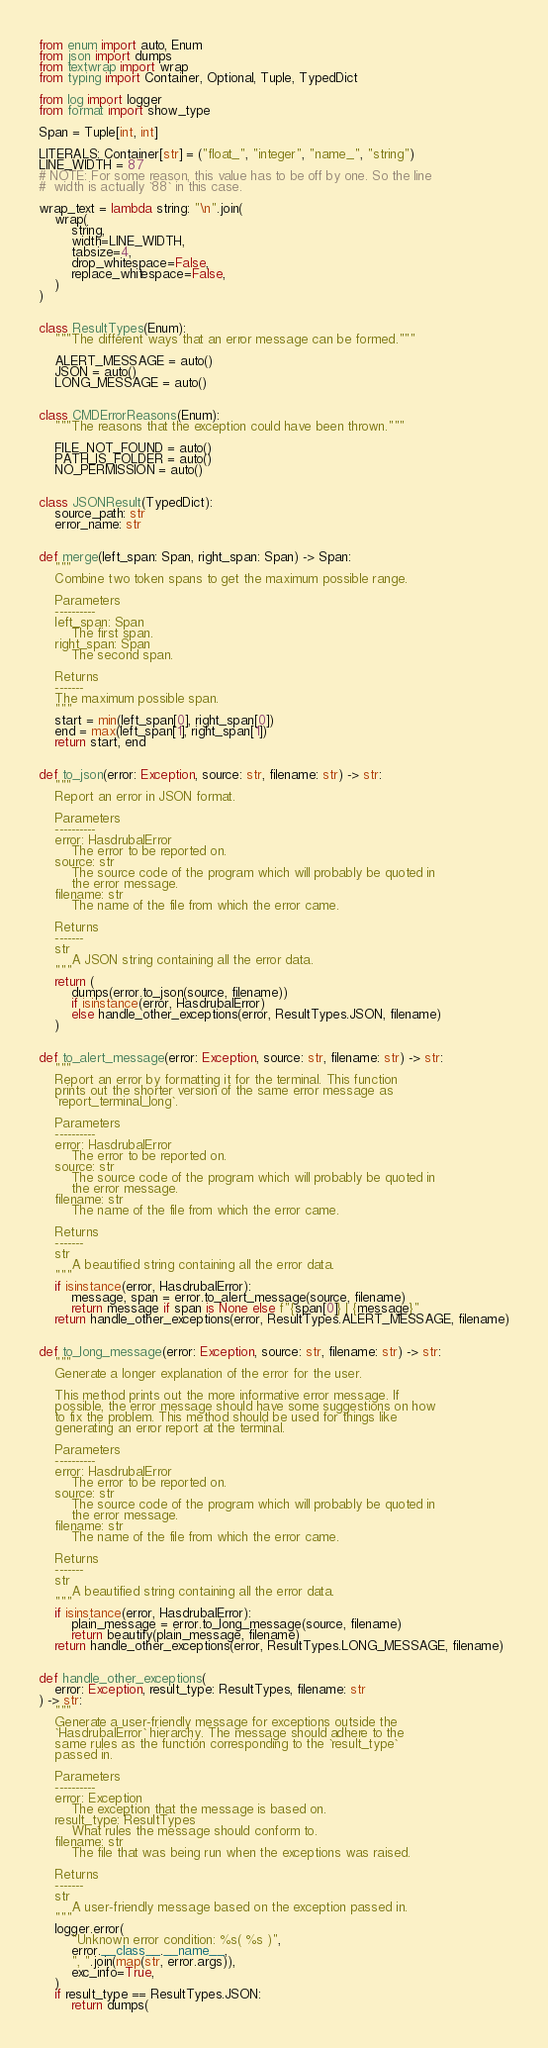<code> <loc_0><loc_0><loc_500><loc_500><_Python_>from enum import auto, Enum
from json import dumps
from textwrap import wrap
from typing import Container, Optional, Tuple, TypedDict

from log import logger
from format import show_type

Span = Tuple[int, int]

LITERALS: Container[str] = ("float_", "integer", "name_", "string")
LINE_WIDTH = 87
# NOTE: For some reason, this value has to be off by one. So the line
#  width is actually `88` in this case.

wrap_text = lambda string: "\n".join(
    wrap(
        string,
        width=LINE_WIDTH,
        tabsize=4,
        drop_whitespace=False,
        replace_whitespace=False,
    )
)


class ResultTypes(Enum):
    """The different ways that an error message can be formed."""

    ALERT_MESSAGE = auto()
    JSON = auto()
    LONG_MESSAGE = auto()


class CMDErrorReasons(Enum):
    """The reasons that the exception could have been thrown."""

    FILE_NOT_FOUND = auto()
    PATH_IS_FOLDER = auto()
    NO_PERMISSION = auto()


class JSONResult(TypedDict):
    source_path: str
    error_name: str


def merge(left_span: Span, right_span: Span) -> Span:
    """
    Combine two token spans to get the maximum possible range.

    Parameters
    ----------
    left_span: Span
        The first span.
    right_span: Span
        The second span.

    Returns
    -------
    The maximum possible span.
    """
    start = min(left_span[0], right_span[0])
    end = max(left_span[1], right_span[1])
    return start, end


def to_json(error: Exception, source: str, filename: str) -> str:
    """
    Report an error in JSON format.

    Parameters
    ----------
    error: HasdrubalError
        The error to be reported on.
    source: str
        The source code of the program which will probably be quoted in
        the error message.
    filename: str
        The name of the file from which the error came.

    Returns
    -------
    str
        A JSON string containing all the error data.
    """
    return (
        dumps(error.to_json(source, filename))
        if isinstance(error, HasdrubalError)
        else handle_other_exceptions(error, ResultTypes.JSON, filename)
    )


def to_alert_message(error: Exception, source: str, filename: str) -> str:
    """
    Report an error by formatting it for the terminal. This function
    prints out the shorter version of the same error message as
    `report_terminal_long`.

    Parameters
    ----------
    error: HasdrubalError
        The error to be reported on.
    source: str
        The source code of the program which will probably be quoted in
        the error message.
    filename: str
        The name of the file from which the error came.

    Returns
    -------
    str
        A beautified string containing all the error data.
    """
    if isinstance(error, HasdrubalError):
        message, span = error.to_alert_message(source, filename)
        return message if span is None else f"{span[0]} | {message}"
    return handle_other_exceptions(error, ResultTypes.ALERT_MESSAGE, filename)


def to_long_message(error: Exception, source: str, filename: str) -> str:
    """
    Generate a longer explanation of the error for the user.

    This method prints out the more informative error message. If
    possible, the error message should have some suggestions on how
    to fix the problem. This method should be used for things like
    generating an error report at the terminal.

    Parameters
    ----------
    error: HasdrubalError
        The error to be reported on.
    source: str
        The source code of the program which will probably be quoted in
        the error message.
    filename: str
        The name of the file from which the error came.

    Returns
    -------
    str
        A beautified string containing all the error data.
    """
    if isinstance(error, HasdrubalError):
        plain_message = error.to_long_message(source, filename)
        return beautify(plain_message, filename)
    return handle_other_exceptions(error, ResultTypes.LONG_MESSAGE, filename)


def handle_other_exceptions(
    error: Exception, result_type: ResultTypes, filename: str
) -> str:
    """
    Generate a user-friendly message for exceptions outside the
    `HasdrubalError` hierarchy. The message should adhere to the
    same rules as the function corresponding to the `result_type`
    passed in.

    Parameters
    ----------
    error: Exception
        The exception that the message is based on.
    result_type: ResultTypes
        What rules the message should conform to.
    filename: str
        The file that was being run when the exceptions was raised.

    Returns
    -------
    str
        A user-friendly message based on the exception passed in.
    """
    logger.error(
        "Unknown error condition: %s( %s )",
        error.__class__.__name__,
        ", ".join(map(str, error.args)),
        exc_info=True,
    )
    if result_type == ResultTypes.JSON:
        return dumps(</code> 